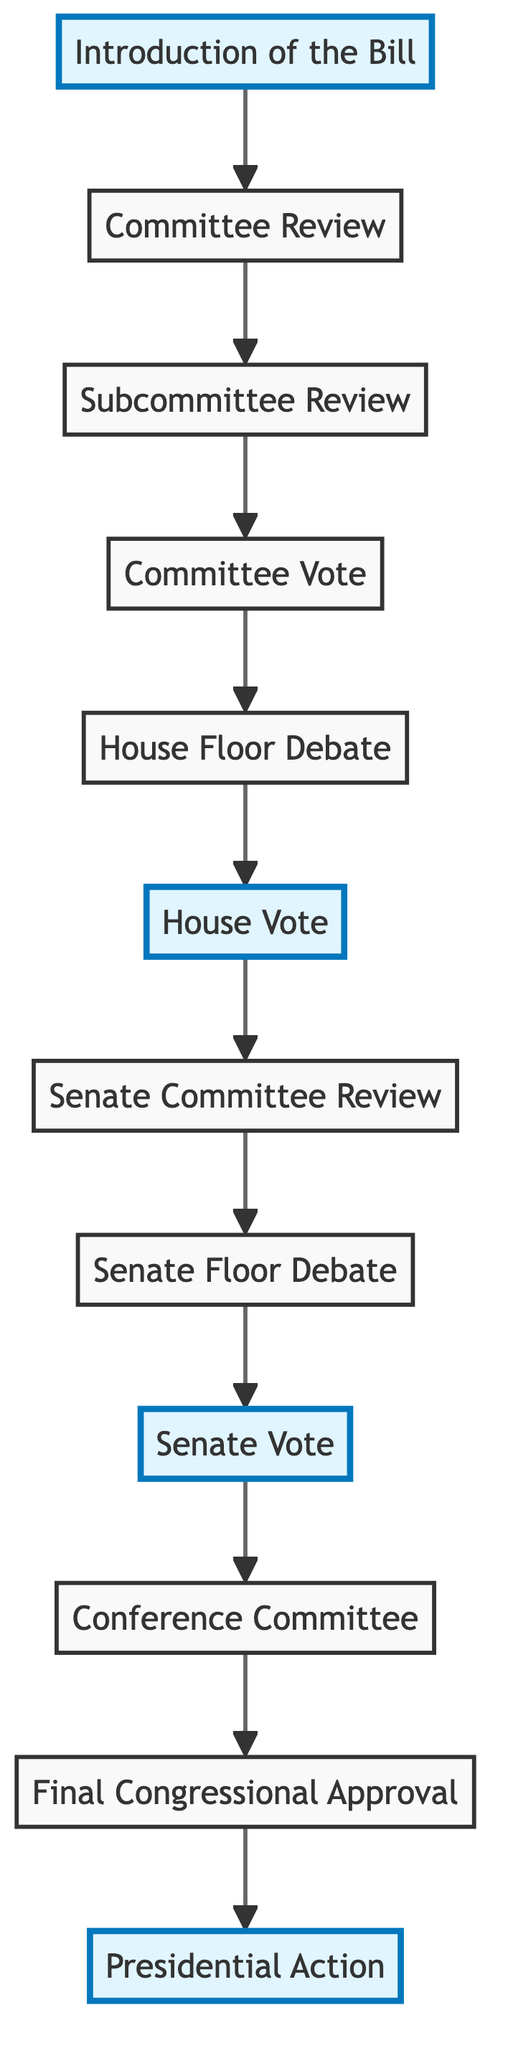What is the first step in the legislative process for healthcare bills? The first step is shown as "Introduction of the Bill," which indicates that a member of Congress drafts and introduces a healthcare bill.
Answer: Introduction of the Bill How many main steps are there in the healthcare legislation process? By counting the elements connected in the flowchart, there are a total of twelve main steps represented.
Answer: Twelve What occurs immediately after the Committee Review? The diagram shows that the step that comes right after "Committee Review" is "Subcommittee Review."
Answer: Subcommittee Review Which steps highlight critical voting points in the process? Analyzing the highlighted steps, "House Vote," "Senate Vote," and "Final Congressional Approval" are the significant voting points that are emphasized.
Answer: House Vote, Senate Vote, Final Congressional Approval What happens after the House Vote if the bill is not approved? According to the flowchart, if the bill is not approved in the House Vote, it is sent back for revisions.
Answer: Sent back for revisions What is the role of the Conference Committee in the process? The "Conference Committee" step highlights that its role is to reconcile differences between the House and Senate versions of the bill before moving forward.
Answer: Reconcile differences After the Senate Vote, what determines whether the bill moves to the President? The result of the Senate Vote determines if it moves to the President, specifically if the bill passed without any amendments, allowing it to progress.
Answer: Passed without amendments How many committees review the bill in total before it reaches the President? The bill is reviewed by three committees: one in the House, one in the Senate, and a Conference Committee, totaling three committees.
Answer: Three committees What does the Presidential Action entail at the last step? The "Presidential Action" step describes that the President can either sign the bill into law, veto it, or take no action which can lead to various outcomes.
Answer: Sign, veto, or no action 